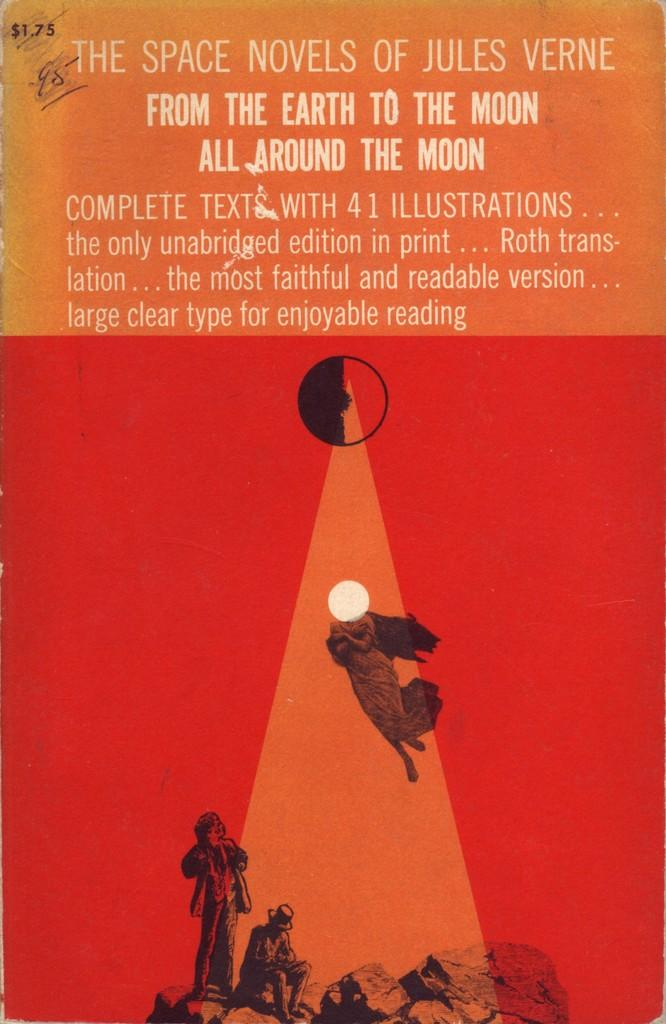What is present in the image that contains visuals and text? There is a poster in the image that contains pictures and text. Can you describe the pictures on the poster? Unfortunately, the specific pictures on the poster cannot be described without more information. What type of information is conveyed through the text on the poster? The content of the text on the poster cannot be determined without more information. Where is the faucet located in the image? There is no faucet present in the image. What scientific theory is being explained on the poster? The image does not depict a poster explaining a scientific theory. 